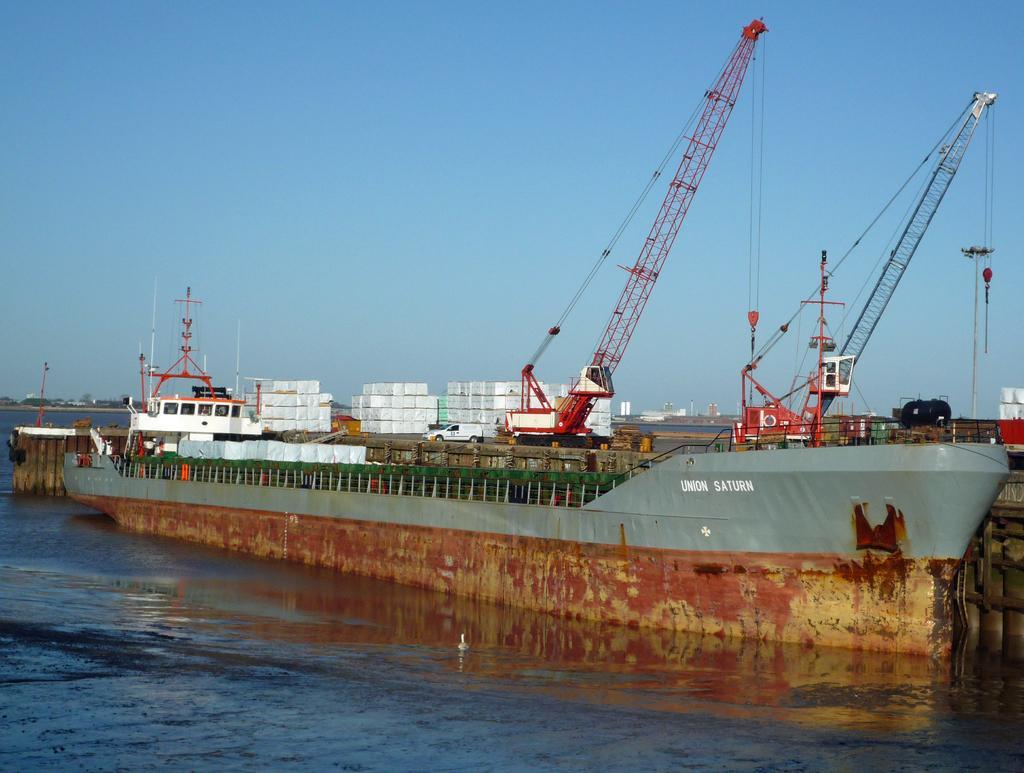Please provide a concise description of this image. In this picture we can see a ship on water, vehicles, excavators and in the background we can see the sky. 